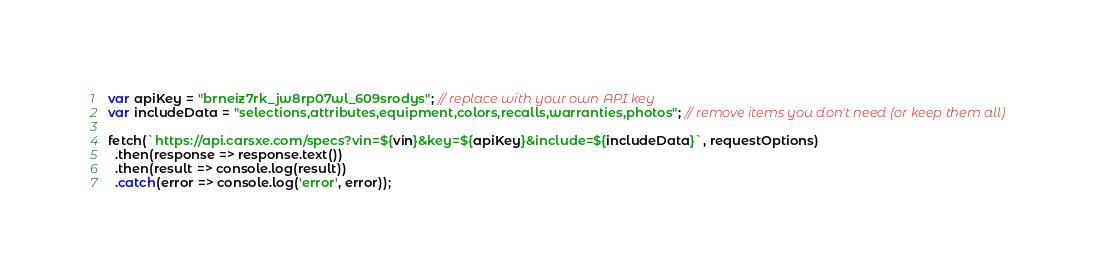Convert code to text. <code><loc_0><loc_0><loc_500><loc_500><_JavaScript_>var apiKey = "brneiz7rk_jw8rp07wl_609srodys"; // replace with your own API key
var includeData = "selections,attributes,equipment,colors,recalls,warranties,photos"; // remove items you don't need (or keep them all)

fetch(`https://api.carsxe.com/specs?vin=${vin}&key=${apiKey}&include=${includeData}`, requestOptions)
  .then(response => response.text())
  .then(result => console.log(result))
  .catch(error => console.log('error', error));
</code> 